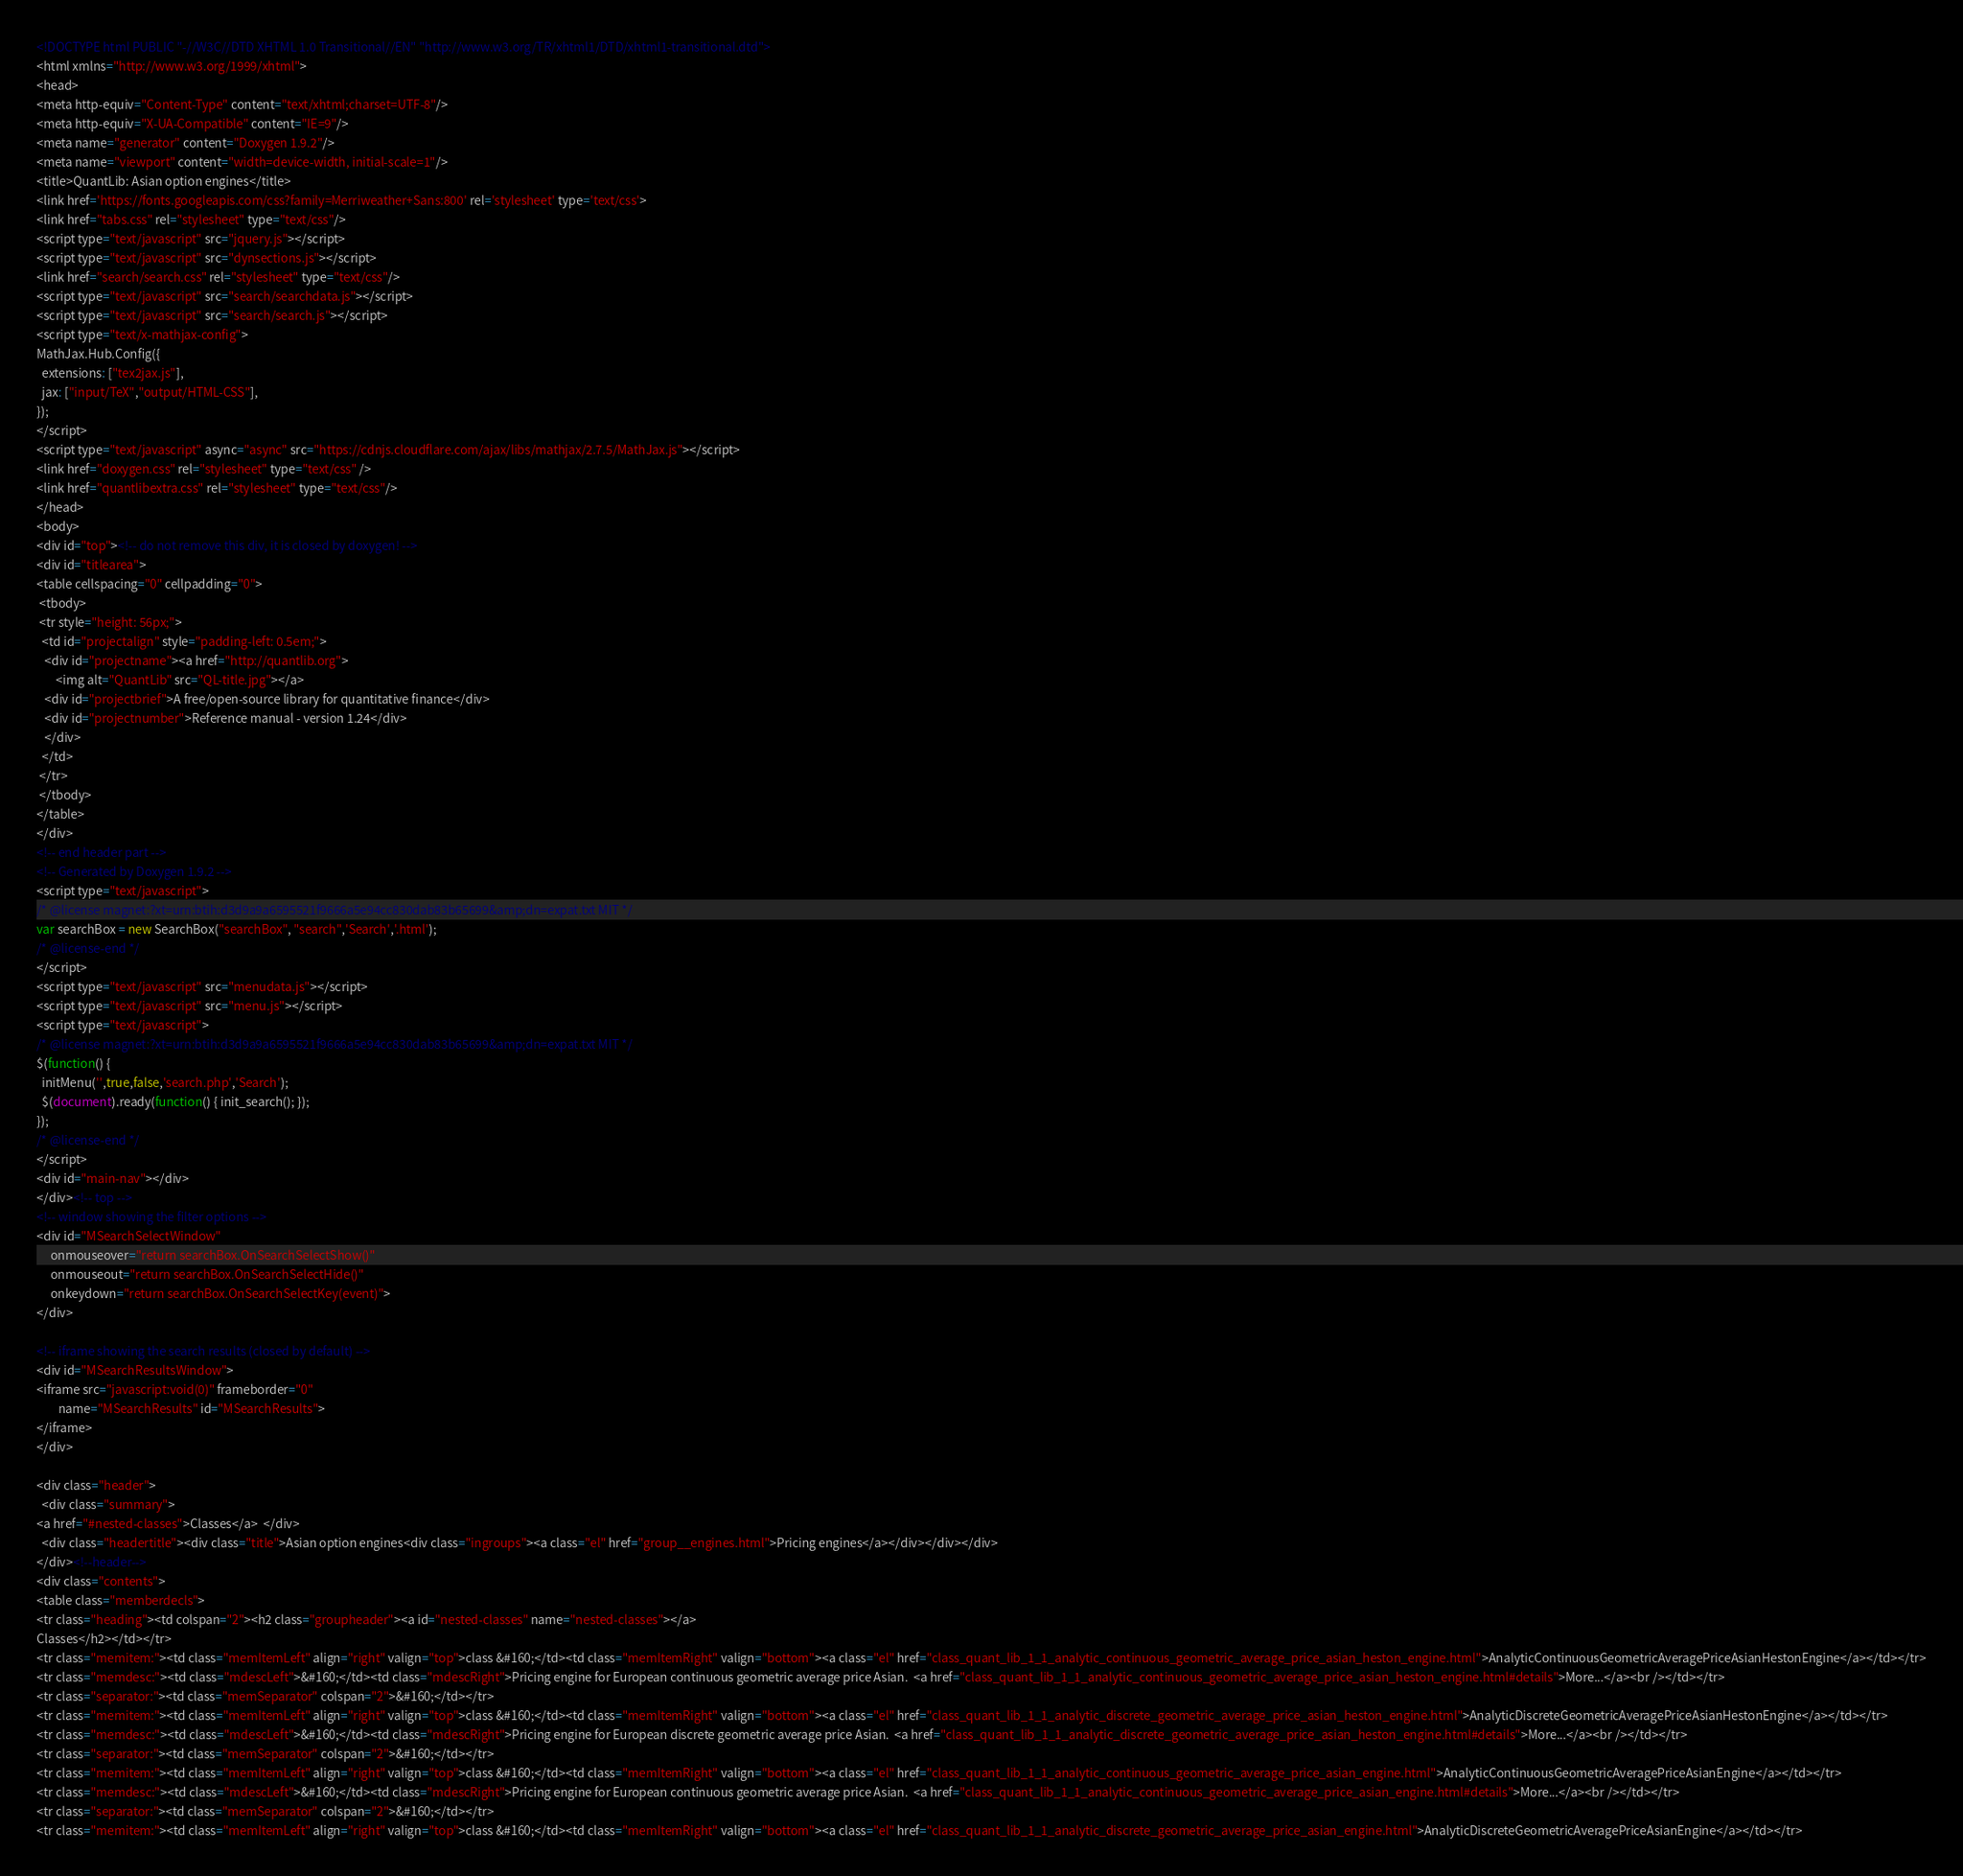Convert code to text. <code><loc_0><loc_0><loc_500><loc_500><_HTML_><!DOCTYPE html PUBLIC "-//W3C//DTD XHTML 1.0 Transitional//EN" "http://www.w3.org/TR/xhtml1/DTD/xhtml1-transitional.dtd">
<html xmlns="http://www.w3.org/1999/xhtml">
<head>
<meta http-equiv="Content-Type" content="text/xhtml;charset=UTF-8"/>
<meta http-equiv="X-UA-Compatible" content="IE=9"/>
<meta name="generator" content="Doxygen 1.9.2"/>
<meta name="viewport" content="width=device-width, initial-scale=1"/>
<title>QuantLib: Asian option engines</title>
<link href='https://fonts.googleapis.com/css?family=Merriweather+Sans:800' rel='stylesheet' type='text/css'>
<link href="tabs.css" rel="stylesheet" type="text/css"/>
<script type="text/javascript" src="jquery.js"></script>
<script type="text/javascript" src="dynsections.js"></script>
<link href="search/search.css" rel="stylesheet" type="text/css"/>
<script type="text/javascript" src="search/searchdata.js"></script>
<script type="text/javascript" src="search/search.js"></script>
<script type="text/x-mathjax-config">
MathJax.Hub.Config({
  extensions: ["tex2jax.js"],
  jax: ["input/TeX","output/HTML-CSS"],
});
</script>
<script type="text/javascript" async="async" src="https://cdnjs.cloudflare.com/ajax/libs/mathjax/2.7.5/MathJax.js"></script>
<link href="doxygen.css" rel="stylesheet" type="text/css" />
<link href="quantlibextra.css" rel="stylesheet" type="text/css"/>
</head>
<body>
<div id="top"><!-- do not remove this div, it is closed by doxygen! -->
<div id="titlearea">
<table cellspacing="0" cellpadding="0">
 <tbody>
 <tr style="height: 56px;">
  <td id="projectalign" style="padding-left: 0.5em;">
   <div id="projectname"><a href="http://quantlib.org">
       <img alt="QuantLib" src="QL-title.jpg"></a>
   <div id="projectbrief">A free/open-source library for quantitative finance</div>
   <div id="projectnumber">Reference manual - version 1.24</div>
   </div>
  </td>
 </tr>
 </tbody>
</table>
</div>
<!-- end header part -->
<!-- Generated by Doxygen 1.9.2 -->
<script type="text/javascript">
/* @license magnet:?xt=urn:btih:d3d9a9a6595521f9666a5e94cc830dab83b65699&amp;dn=expat.txt MIT */
var searchBox = new SearchBox("searchBox", "search",'Search','.html');
/* @license-end */
</script>
<script type="text/javascript" src="menudata.js"></script>
<script type="text/javascript" src="menu.js"></script>
<script type="text/javascript">
/* @license magnet:?xt=urn:btih:d3d9a9a6595521f9666a5e94cc830dab83b65699&amp;dn=expat.txt MIT */
$(function() {
  initMenu('',true,false,'search.php','Search');
  $(document).ready(function() { init_search(); });
});
/* @license-end */
</script>
<div id="main-nav"></div>
</div><!-- top -->
<!-- window showing the filter options -->
<div id="MSearchSelectWindow"
     onmouseover="return searchBox.OnSearchSelectShow()"
     onmouseout="return searchBox.OnSearchSelectHide()"
     onkeydown="return searchBox.OnSearchSelectKey(event)">
</div>

<!-- iframe showing the search results (closed by default) -->
<div id="MSearchResultsWindow">
<iframe src="javascript:void(0)" frameborder="0" 
        name="MSearchResults" id="MSearchResults">
</iframe>
</div>

<div class="header">
  <div class="summary">
<a href="#nested-classes">Classes</a>  </div>
  <div class="headertitle"><div class="title">Asian option engines<div class="ingroups"><a class="el" href="group__engines.html">Pricing engines</a></div></div></div>
</div><!--header-->
<div class="contents">
<table class="memberdecls">
<tr class="heading"><td colspan="2"><h2 class="groupheader"><a id="nested-classes" name="nested-classes"></a>
Classes</h2></td></tr>
<tr class="memitem:"><td class="memItemLeft" align="right" valign="top">class &#160;</td><td class="memItemRight" valign="bottom"><a class="el" href="class_quant_lib_1_1_analytic_continuous_geometric_average_price_asian_heston_engine.html">AnalyticContinuousGeometricAveragePriceAsianHestonEngine</a></td></tr>
<tr class="memdesc:"><td class="mdescLeft">&#160;</td><td class="mdescRight">Pricing engine for European continuous geometric average price Asian.  <a href="class_quant_lib_1_1_analytic_continuous_geometric_average_price_asian_heston_engine.html#details">More...</a><br /></td></tr>
<tr class="separator:"><td class="memSeparator" colspan="2">&#160;</td></tr>
<tr class="memitem:"><td class="memItemLeft" align="right" valign="top">class &#160;</td><td class="memItemRight" valign="bottom"><a class="el" href="class_quant_lib_1_1_analytic_discrete_geometric_average_price_asian_heston_engine.html">AnalyticDiscreteGeometricAveragePriceAsianHestonEngine</a></td></tr>
<tr class="memdesc:"><td class="mdescLeft">&#160;</td><td class="mdescRight">Pricing engine for European discrete geometric average price Asian.  <a href="class_quant_lib_1_1_analytic_discrete_geometric_average_price_asian_heston_engine.html#details">More...</a><br /></td></tr>
<tr class="separator:"><td class="memSeparator" colspan="2">&#160;</td></tr>
<tr class="memitem:"><td class="memItemLeft" align="right" valign="top">class &#160;</td><td class="memItemRight" valign="bottom"><a class="el" href="class_quant_lib_1_1_analytic_continuous_geometric_average_price_asian_engine.html">AnalyticContinuousGeometricAveragePriceAsianEngine</a></td></tr>
<tr class="memdesc:"><td class="mdescLeft">&#160;</td><td class="mdescRight">Pricing engine for European continuous geometric average price Asian.  <a href="class_quant_lib_1_1_analytic_continuous_geometric_average_price_asian_engine.html#details">More...</a><br /></td></tr>
<tr class="separator:"><td class="memSeparator" colspan="2">&#160;</td></tr>
<tr class="memitem:"><td class="memItemLeft" align="right" valign="top">class &#160;</td><td class="memItemRight" valign="bottom"><a class="el" href="class_quant_lib_1_1_analytic_discrete_geometric_average_price_asian_engine.html">AnalyticDiscreteGeometricAveragePriceAsianEngine</a></td></tr></code> 